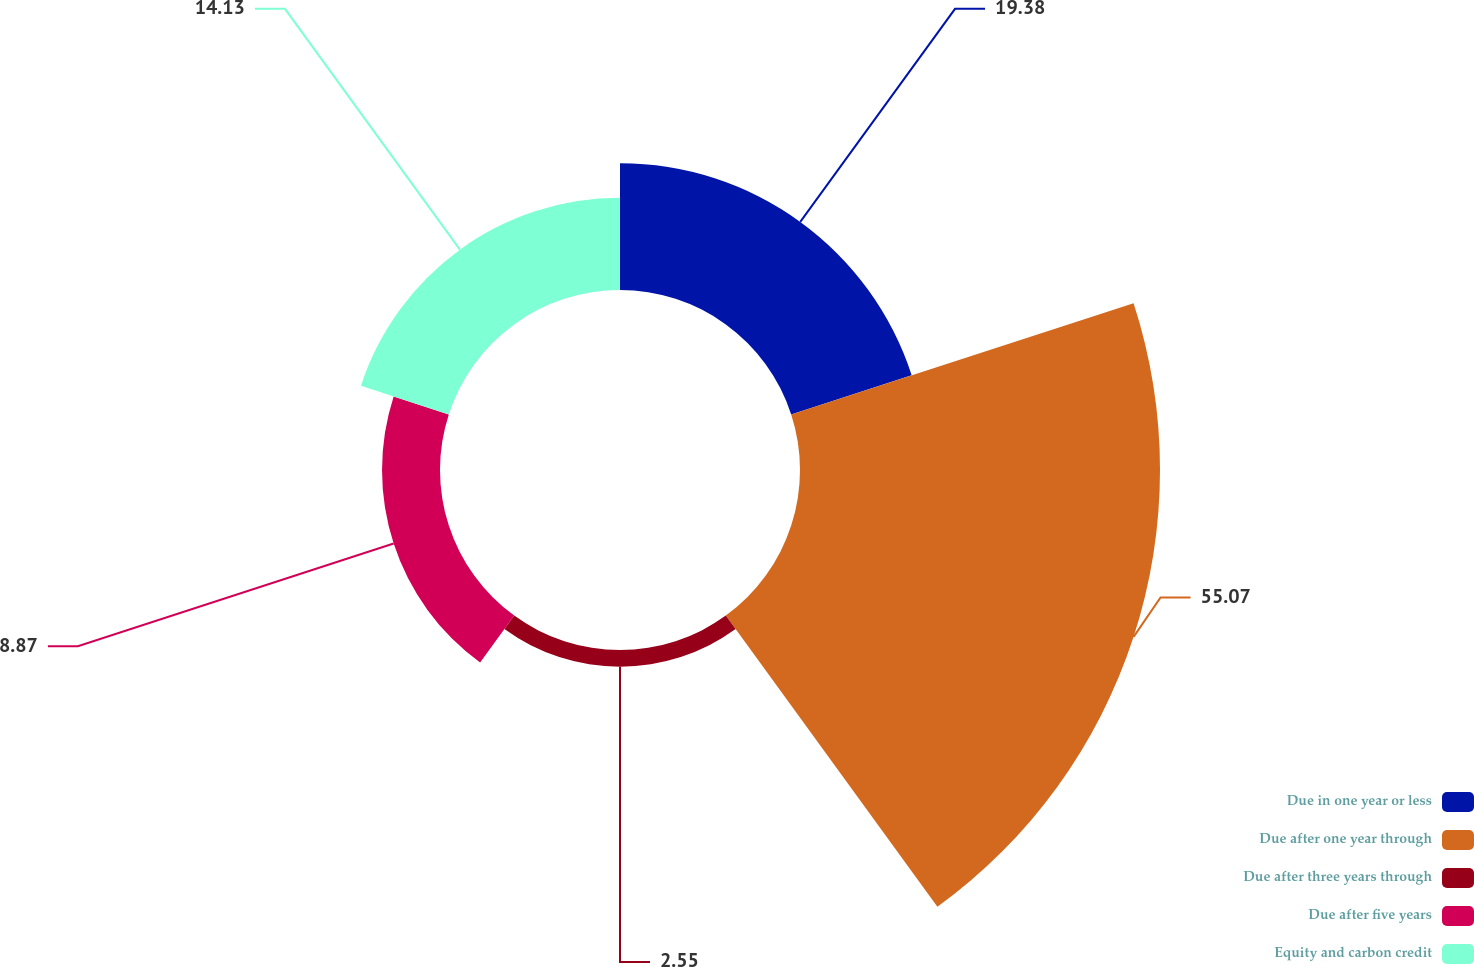Convert chart to OTSL. <chart><loc_0><loc_0><loc_500><loc_500><pie_chart><fcel>Due in one year or less<fcel>Due after one year through<fcel>Due after three years through<fcel>Due after five years<fcel>Equity and carbon credit<nl><fcel>19.38%<fcel>55.07%<fcel>2.55%<fcel>8.87%<fcel>14.13%<nl></chart> 